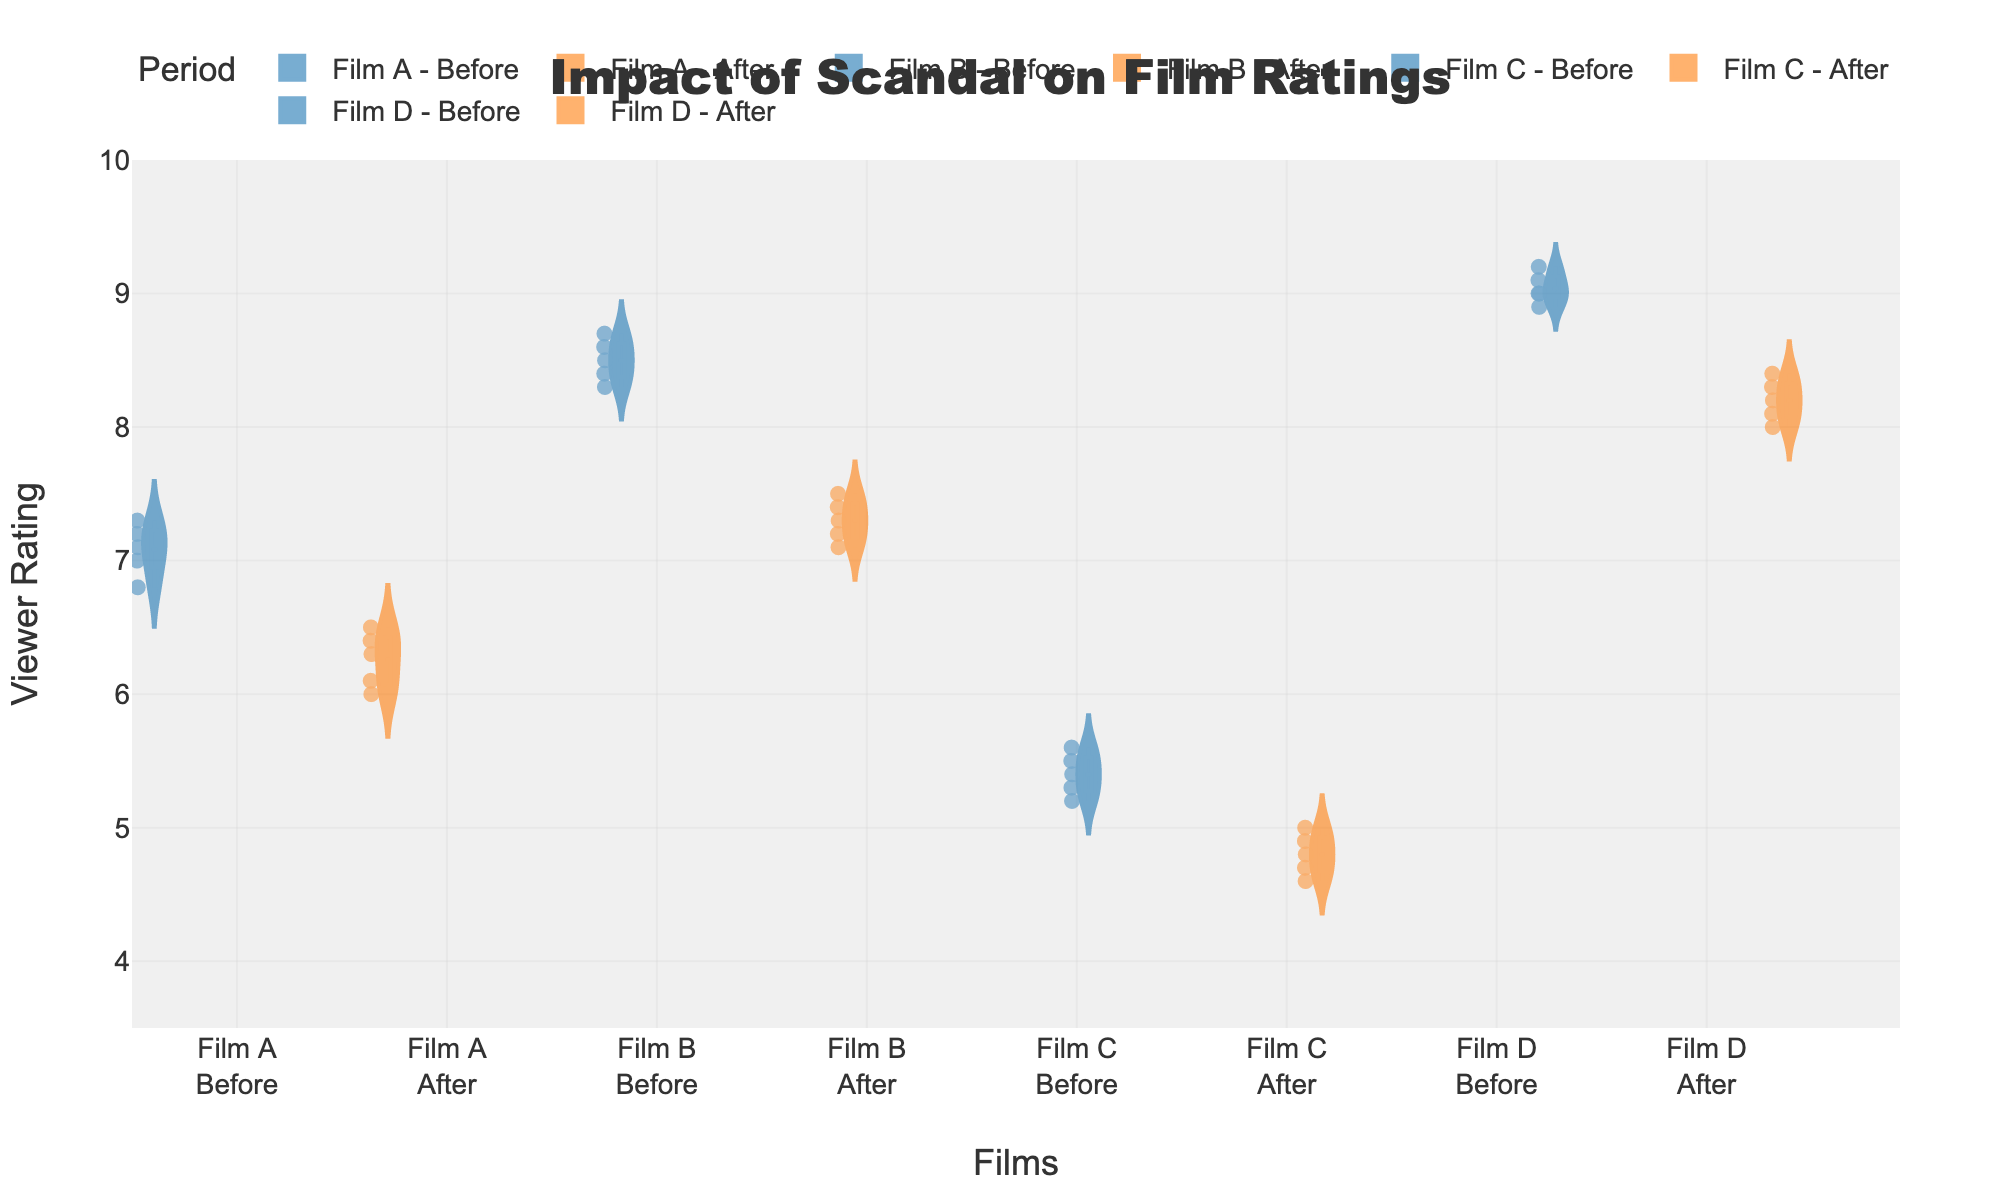What is the title of the violin plot? The title of the violin plot is displayed prominently at the top of the figure. You can read it directly from there.
Answer: Impact of Scandal on Film Ratings Which period, Before or After, generally shows higher viewer ratings for 'Film B'? Compare the violin plots of 'Before' and 'After' periods for 'Film B'. Observe which one appears to have higher values overall.
Answer: Before What film shows the greatest overall drop in viewer ratings after the scandal? Evaluate the median lines in the box plots and the spread of data points for each film before and after the scandal. Identify which film has the greatest decrease in these values.
Answer: Film D What is the median viewer rating for 'Film A' after the scandal? Locate the box plot within the 'After' violin plot for 'Film A'. The median is marked by a horizontal line within the box. Read the value of this line.
Answer: 6.3 Which film has the tightest spread of viewer ratings before the scandal? Look at the width and spread of the violin plots in the 'Before' period for each film. The film with the narrowest plot has the tightest spread.
Answer: Film D What is the mean viewer rating for 'Film C' before the scandal? Use the mean line visible in the box plot overlay within the 'Before' violin plot of 'Film C'. Read the value or approximate from the figure.
Answer: Approximately 5.4 How does the range of viewer ratings for 'Film B' before the scandal compare to after? Compare the spread of the 'Before' violin plot for 'Film B' (from lowest to highest data points) with that of the 'After' plot. Assess the range in both periods.
Answer: Larger range before What is the interquartile range (IQR) of 'Film D' after the scandal? Identify the box plot within the 'After' violin plot for 'Film D'. The IQR is the distance between the upper and lower quartiles (the top and bottom boundaries of the box). Estimate or read these values.
Answer: 0.4 Which period has a lower median rating for 'Film C'? Compare the median lines in the 'Before' and 'After' violin plots for 'Film C'. The plot with the lower median line indicates the lower median rating period.
Answer: After Do any films show an increase in median viewer rating after the scandal? Check the median lines of each film in the 'Before' and 'After' periods. Determine if any film shows a higher median line in the 'After' plot compared to 'Before'.
Answer: No 